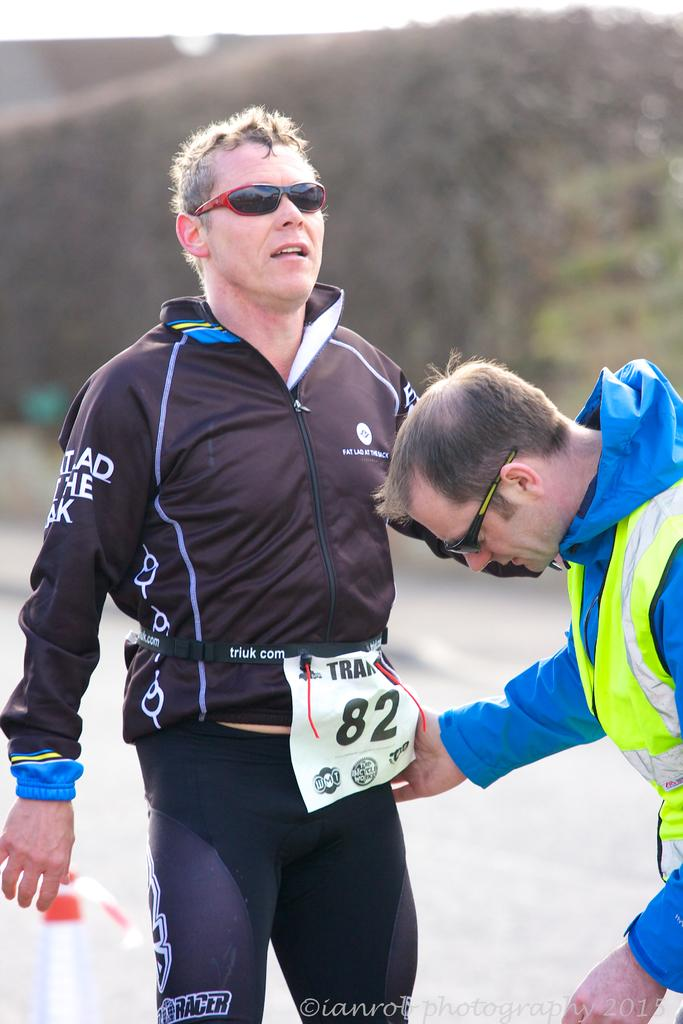<image>
Describe the image concisely. a couple men, one of which wears the number 82 